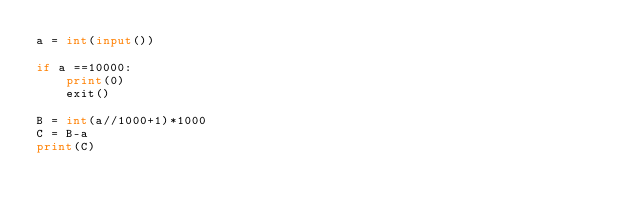<code> <loc_0><loc_0><loc_500><loc_500><_Python_>a = int(input())

if a ==10000:
    print(0)
    exit()

B = int(a//1000+1)*1000
C = B-a
print(C)</code> 